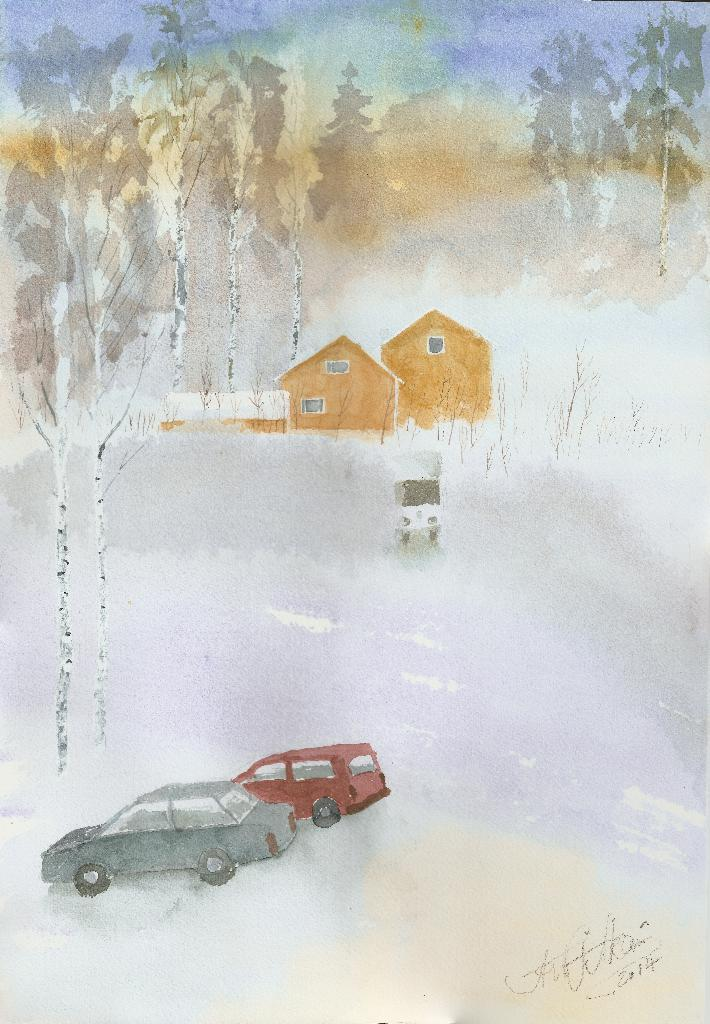What is the main subject of the image? There is a painting in the image. What else can be seen in the image besides the painting? There are cars, houses, and trees in the image. What type of cloth is draped over the fang in the image? There is no cloth or fang present in the image. 